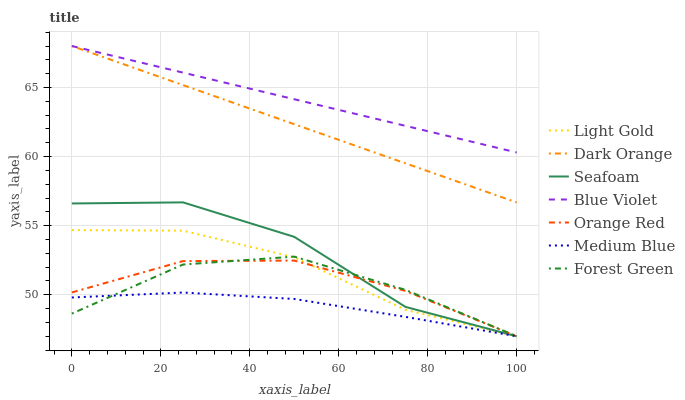Does Medium Blue have the minimum area under the curve?
Answer yes or no. Yes. Does Blue Violet have the maximum area under the curve?
Answer yes or no. Yes. Does Seafoam have the minimum area under the curve?
Answer yes or no. No. Does Seafoam have the maximum area under the curve?
Answer yes or no. No. Is Dark Orange the smoothest?
Answer yes or no. Yes. Is Seafoam the roughest?
Answer yes or no. Yes. Is Medium Blue the smoothest?
Answer yes or no. No. Is Medium Blue the roughest?
Answer yes or no. No. Does Blue Violet have the lowest value?
Answer yes or no. No. Does Blue Violet have the highest value?
Answer yes or no. Yes. Does Seafoam have the highest value?
Answer yes or no. No. Is Seafoam less than Dark Orange?
Answer yes or no. Yes. Is Blue Violet greater than Orange Red?
Answer yes or no. Yes. Does Medium Blue intersect Orange Red?
Answer yes or no. Yes. Is Medium Blue less than Orange Red?
Answer yes or no. No. Is Medium Blue greater than Orange Red?
Answer yes or no. No. Does Seafoam intersect Dark Orange?
Answer yes or no. No. 